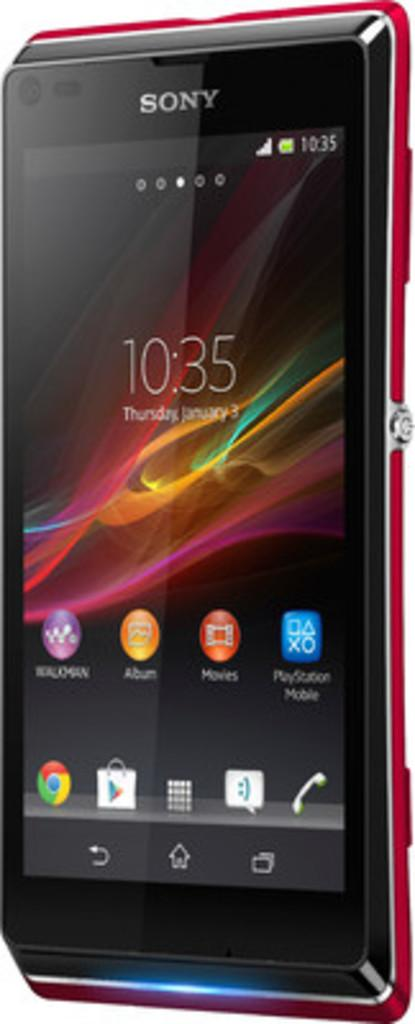<image>
Create a compact narrative representing the image presented. A Sony cell phone home screen with the time reading 10:35. 